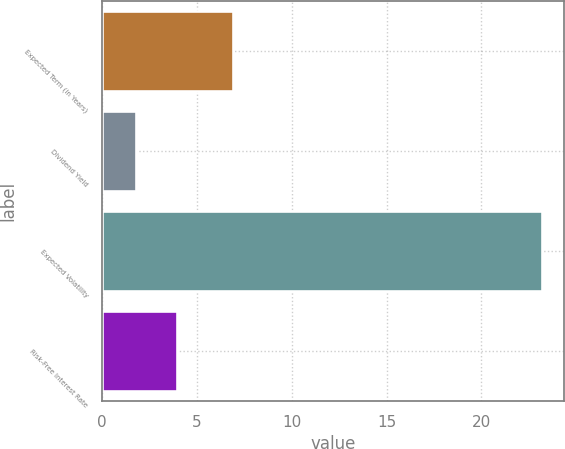<chart> <loc_0><loc_0><loc_500><loc_500><bar_chart><fcel>Expected Term (in Years)<fcel>Dividend Yield<fcel>Expected Volatility<fcel>Risk-Free Interest Rate<nl><fcel>6.9<fcel>1.81<fcel>23.2<fcel>3.95<nl></chart> 